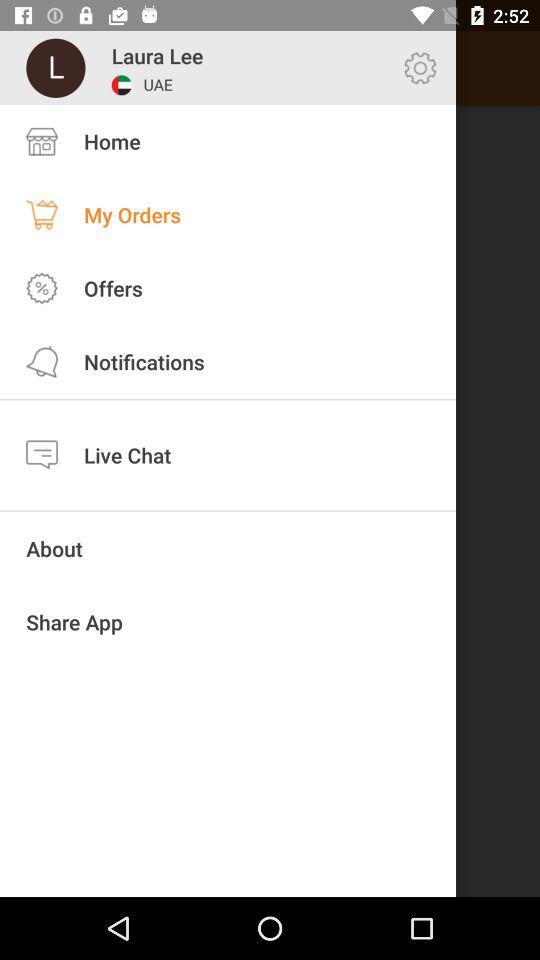Who is in the live chat?
When the provided information is insufficient, respond with <no answer>. <no answer> 